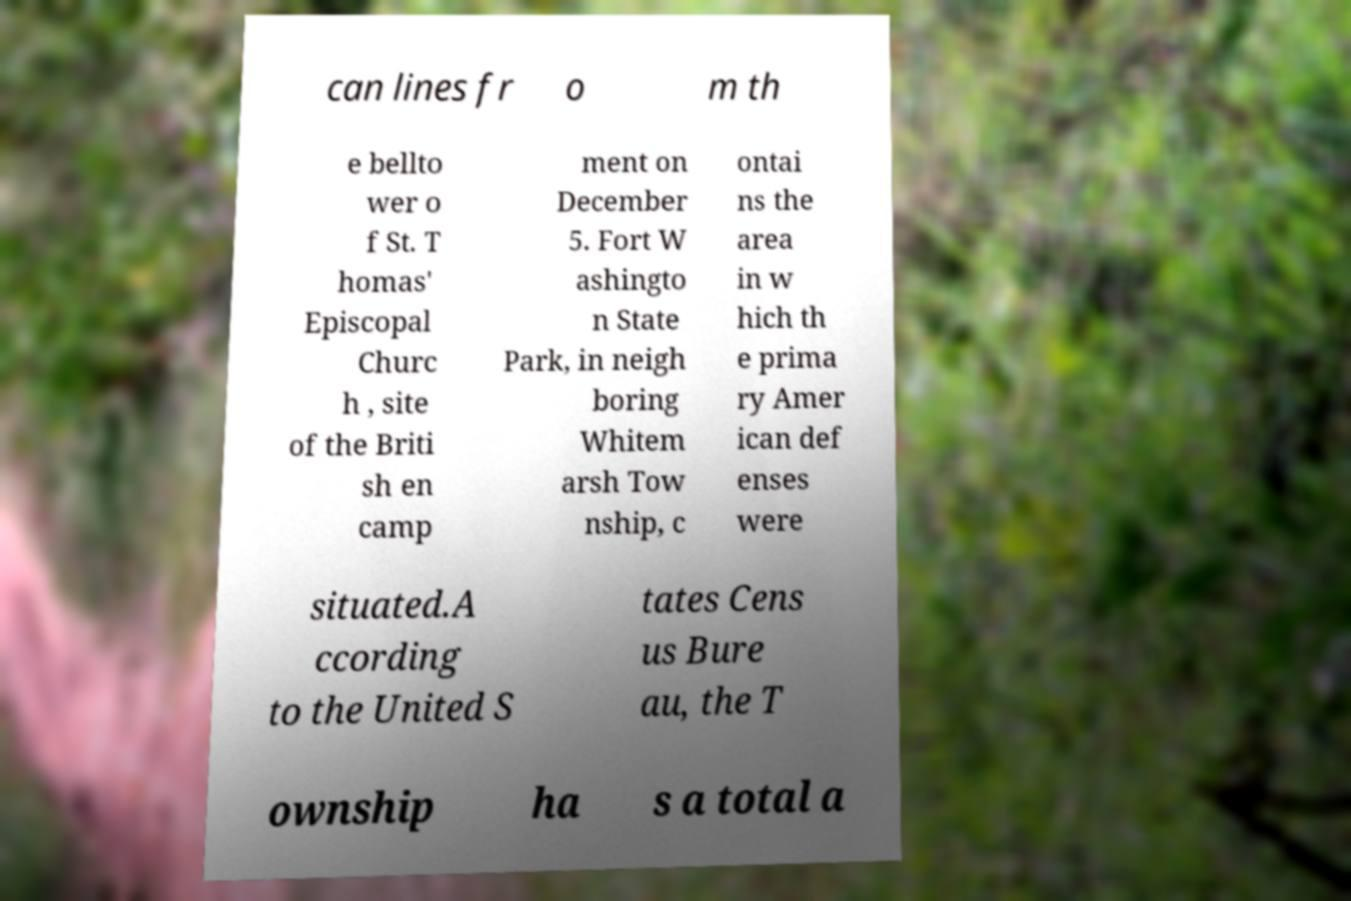What messages or text are displayed in this image? I need them in a readable, typed format. can lines fr o m th e bellto wer o f St. T homas' Episcopal Churc h , site of the Briti sh en camp ment on December 5. Fort W ashingto n State Park, in neigh boring Whitem arsh Tow nship, c ontai ns the area in w hich th e prima ry Amer ican def enses were situated.A ccording to the United S tates Cens us Bure au, the T ownship ha s a total a 